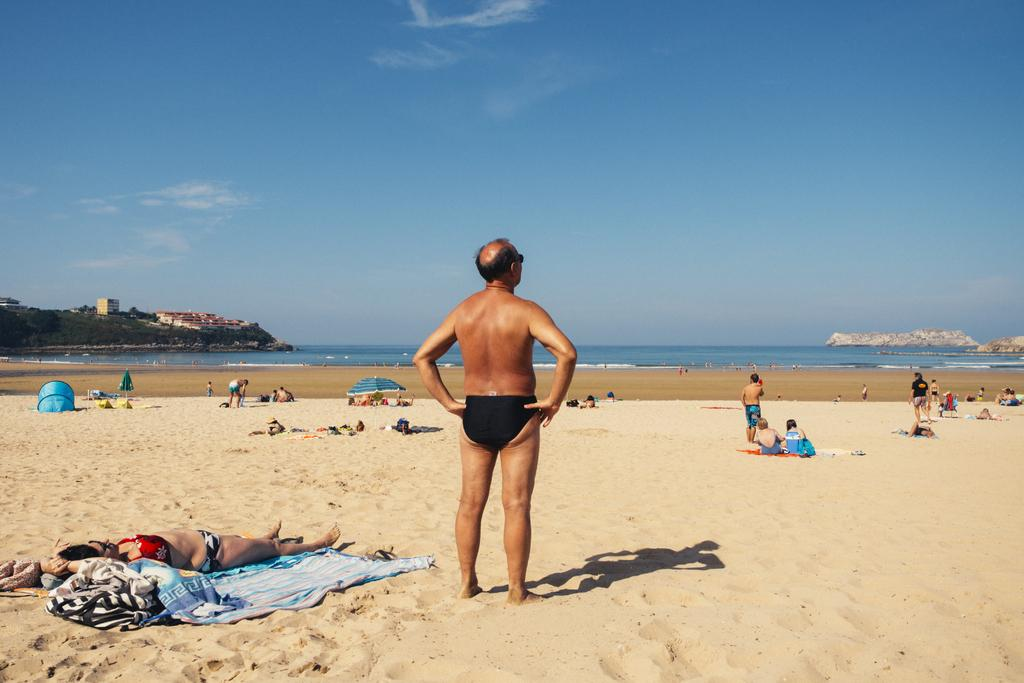What is the main subject in the foreground of the image? There is a man standing on the sand in the foreground of the image. What can be seen in the background of the image? There are persons on the sand, water, buildings, trees, and the sky visible in the background of the image. What is the condition of the sky in the image? The sky is visible in the background of the image, and there are clouds present. How many fangs can be seen on the man in the image? There are no fangs visible on the man in the image, as he is a regular person and not a creature with fangs. 